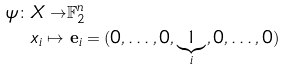Convert formula to latex. <formula><loc_0><loc_0><loc_500><loc_500>\psi \colon X \to & \mathbb { F } _ { 2 } ^ { n } \\ x _ { i } \mapsto \, & \, { \mathbf e } _ { i } = ( 0 , \dots , 0 , \underbrace { 1 } _ { i } , 0 , \dots , 0 )</formula> 